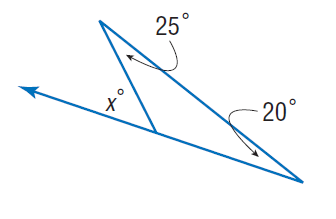Answer the mathemtical geometry problem and directly provide the correct option letter.
Question: Find x.
Choices: A: 20 B: 25 C: 45 D: 55 C 